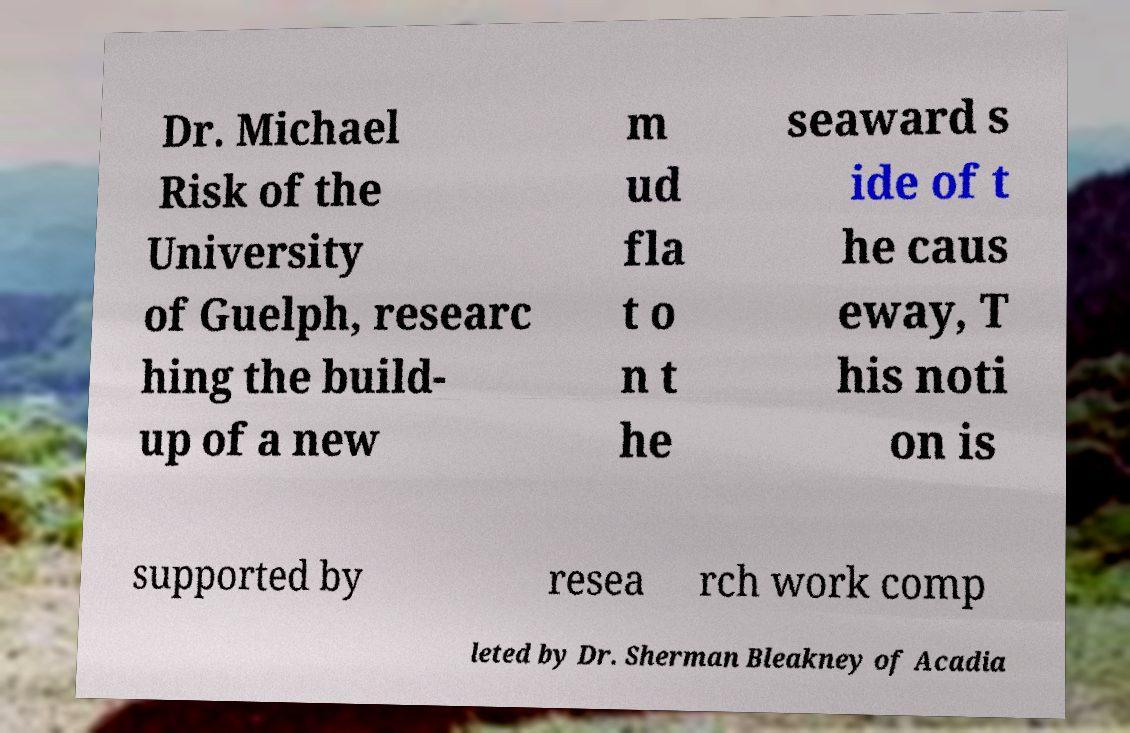Can you accurately transcribe the text from the provided image for me? Dr. Michael Risk of the University of Guelph, researc hing the build- up of a new m ud fla t o n t he seaward s ide of t he caus eway, T his noti on is supported by resea rch work comp leted by Dr. Sherman Bleakney of Acadia 